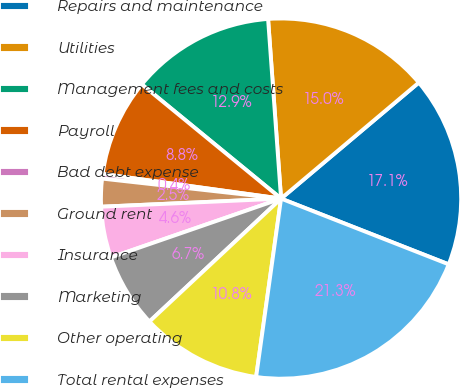<chart> <loc_0><loc_0><loc_500><loc_500><pie_chart><fcel>Repairs and maintenance<fcel>Utilities<fcel>Management fees and costs<fcel>Payroll<fcel>Bad debt expense<fcel>Ground rent<fcel>Insurance<fcel>Marketing<fcel>Other operating<fcel>Total rental expenses<nl><fcel>17.09%<fcel>15.01%<fcel>12.92%<fcel>8.75%<fcel>0.41%<fcel>2.49%<fcel>4.58%<fcel>6.66%<fcel>10.83%<fcel>21.26%<nl></chart> 